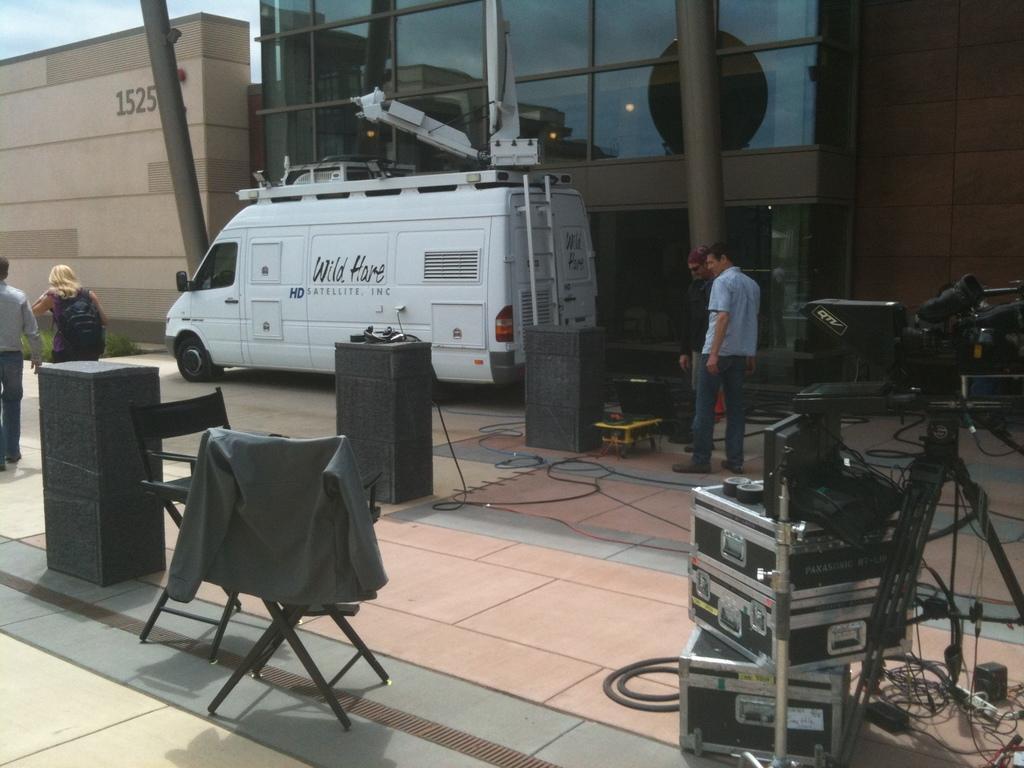Please provide a concise description of this image. In this picture we can see some persons are standing on the road. There is a vehicle and these are some electronic devices. On the background there is a building and this is sky. 